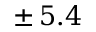<formula> <loc_0><loc_0><loc_500><loc_500>\pm \, 5 . 4</formula> 